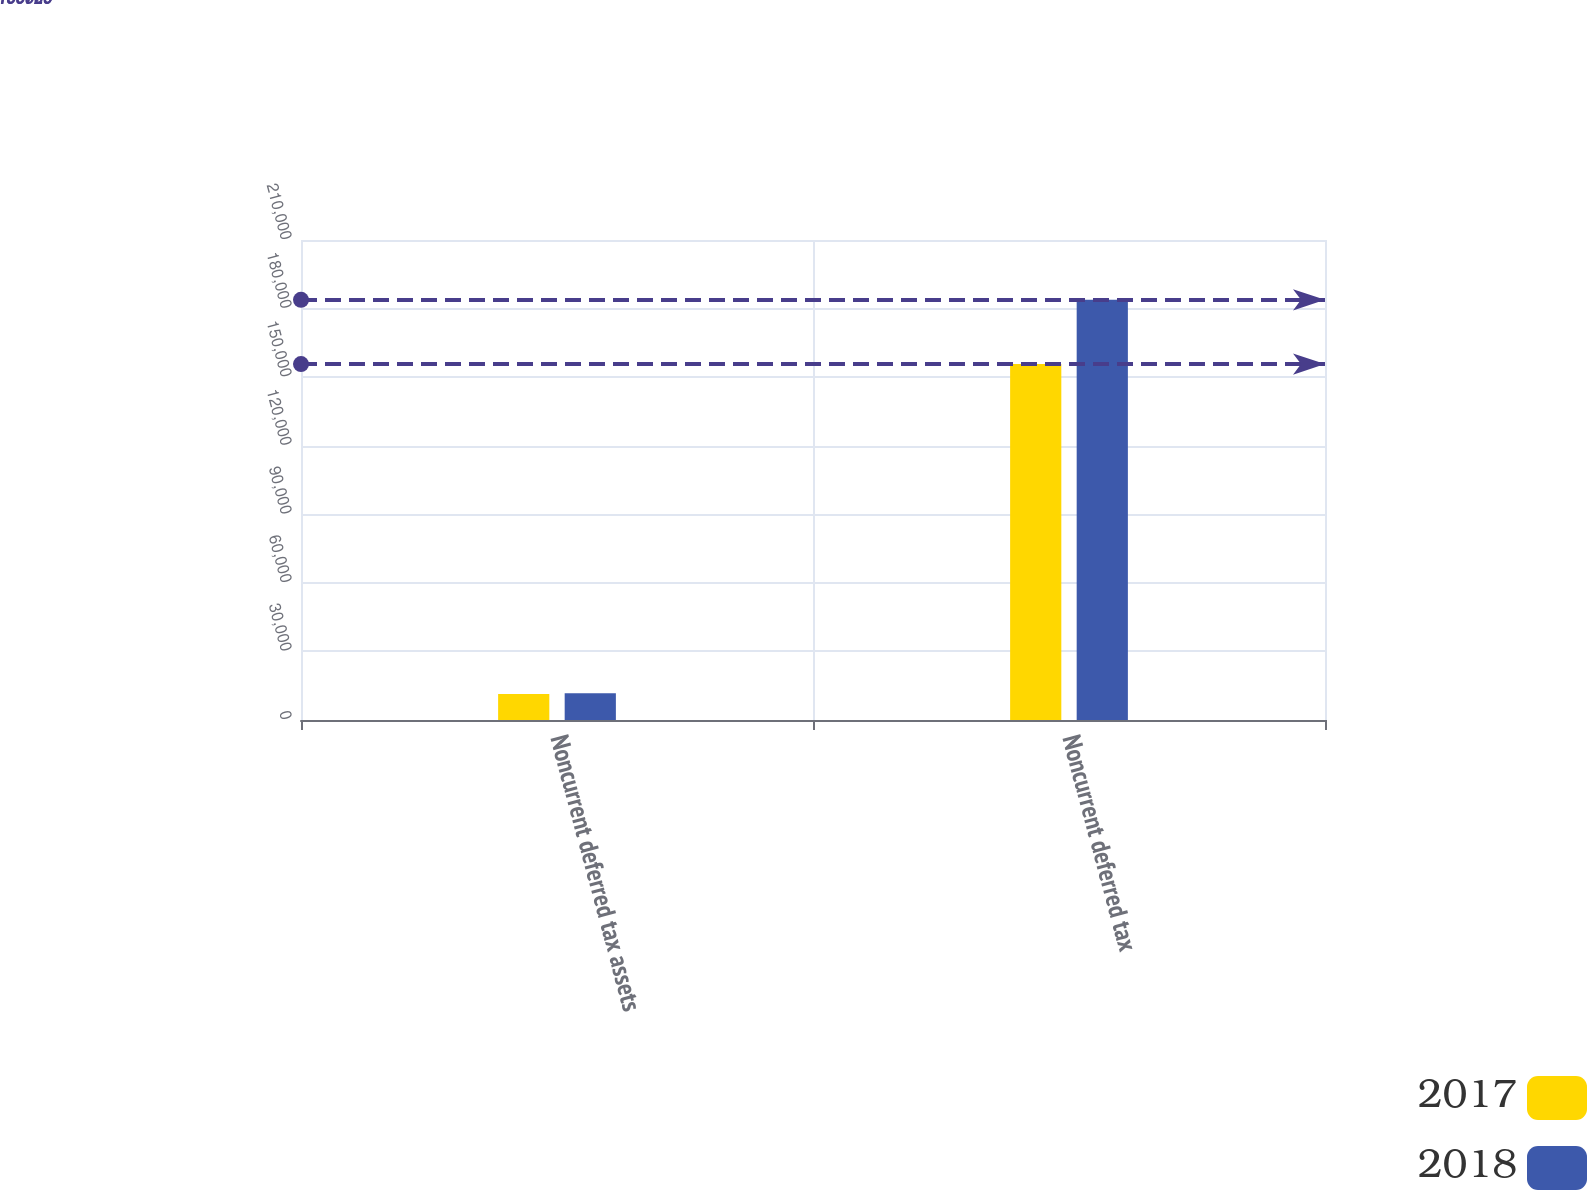<chart> <loc_0><loc_0><loc_500><loc_500><stacked_bar_chart><ecel><fcel>Noncurrent deferred tax assets<fcel>Noncurrent deferred tax<nl><fcel>2017<fcel>11422<fcel>155728<nl><fcel>2018<fcel>11677<fcel>183836<nl></chart> 